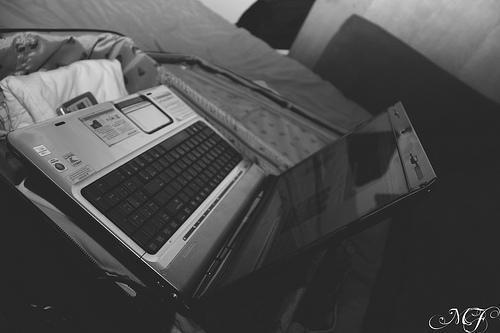How many laptops are there?
Give a very brief answer. 1. 